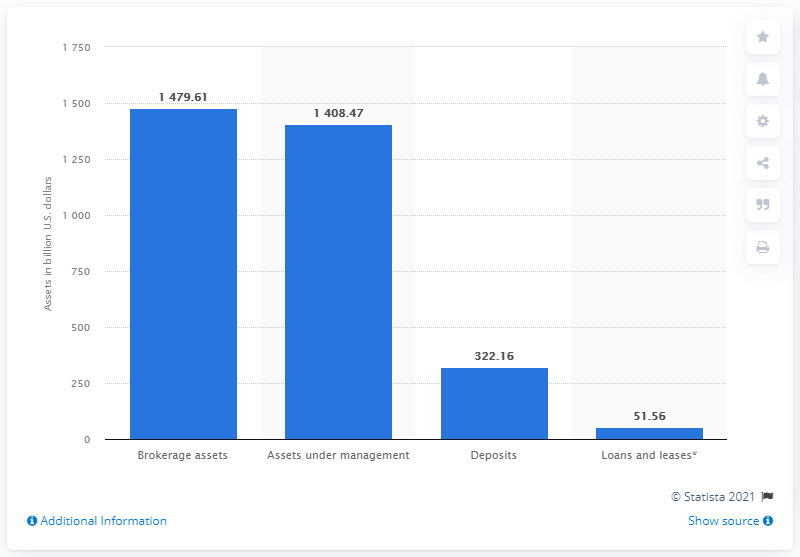Indicate a few pertinent items in this graphic. As of 2020, the value of the brokerage assets held by Bank of America's clients was approximately 1479.61 dollars. As of 2020, the value of Bank of America's assets under management was 1408.47 billion dollars. 